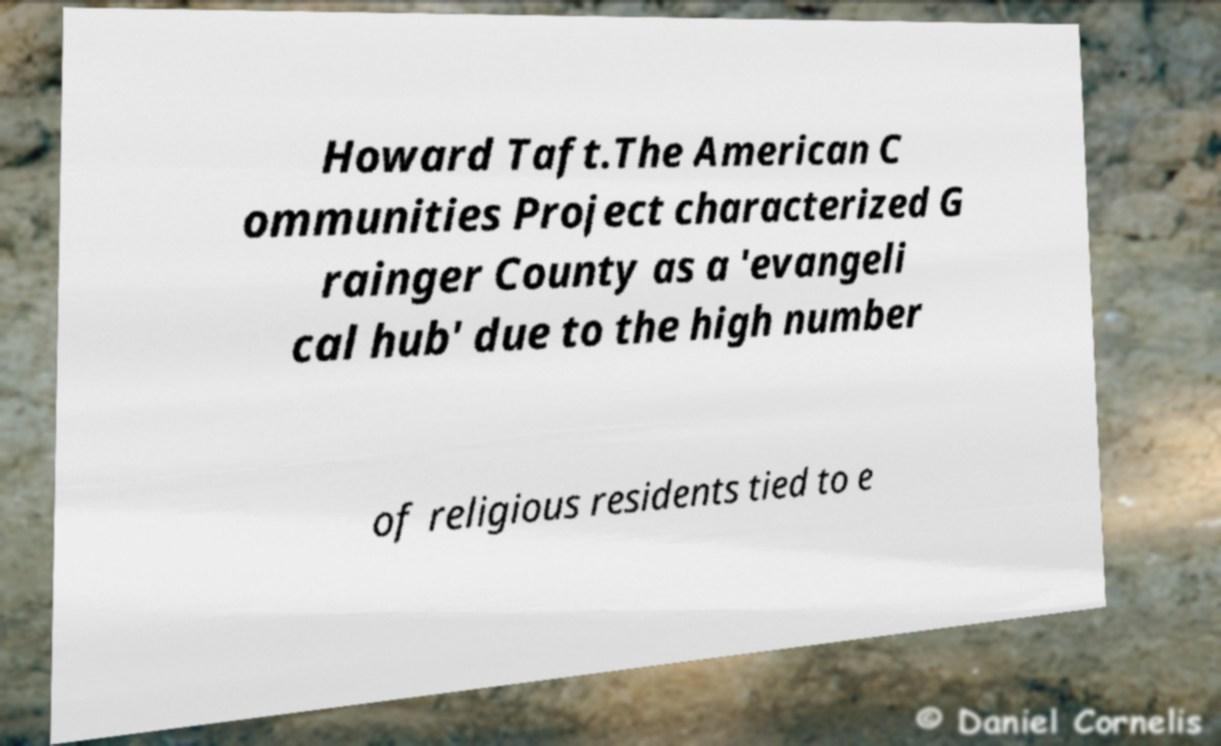For documentation purposes, I need the text within this image transcribed. Could you provide that? Howard Taft.The American C ommunities Project characterized G rainger County as a 'evangeli cal hub' due to the high number of religious residents tied to e 